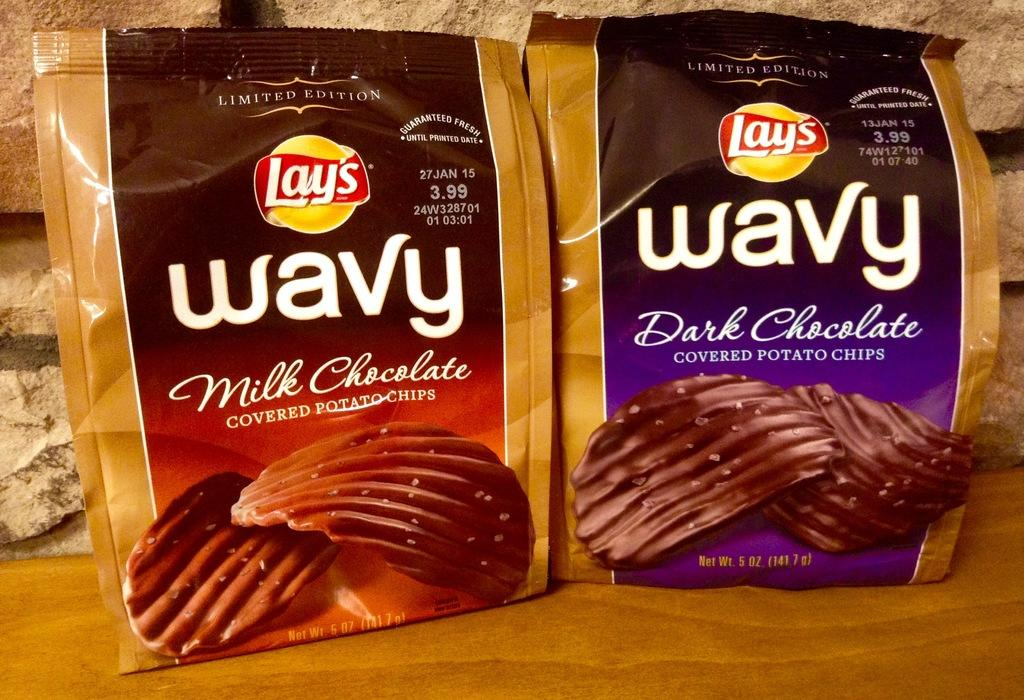What can be seen in the image that is packaged? There are packets in the image. What information is provided on the packets? There is text written on the packets. What can be seen in the background of the image? There is a wall in the background of the image. Reasoning: Let'g: Let's think step by step in order to produce the conversation. We start by identifying the main subject in the image, which are the packets. Then, we expand the conversation to include the text written on the packets and the wall in the background. Each question is designed to elicit a specific detail about the image that is known from the provided facts. Absurd Question/Answer: What type of plot is being used to grow the crops in the image? There is no indication of crops or a plot in the image; it only features packets with text and a wall in the background. How many times have the packets been folded in the image? There is no indication of the packets being folded in the image; they are simply visible with text written on them. 